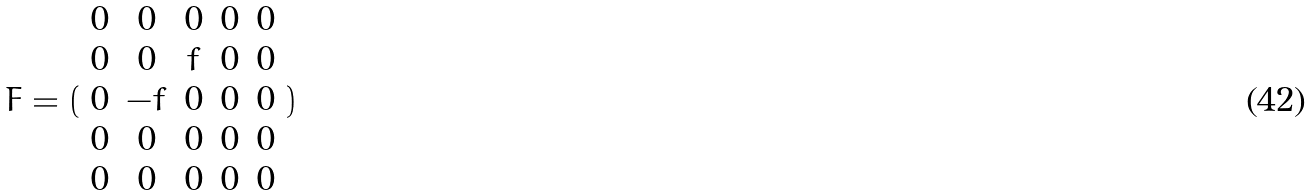<formula> <loc_0><loc_0><loc_500><loc_500>F = ( \begin{array} { c c c c c } 0 & 0 & 0 & 0 & 0 \\ 0 & 0 & f & 0 & 0 \\ 0 & - f & 0 & 0 & 0 \\ 0 & 0 & 0 & 0 & 0 \\ 0 & 0 & 0 & 0 & 0 \end{array} )</formula> 